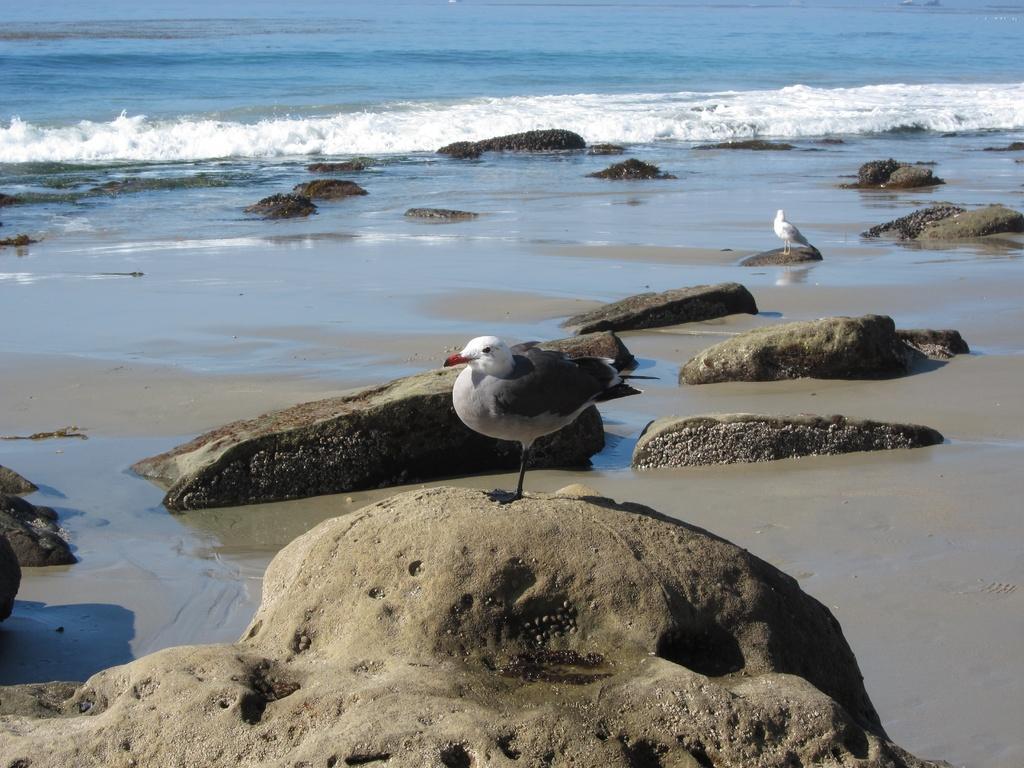How would you summarize this image in a sentence or two? In this image we can see two birds standing on the rocks and water in the background. 